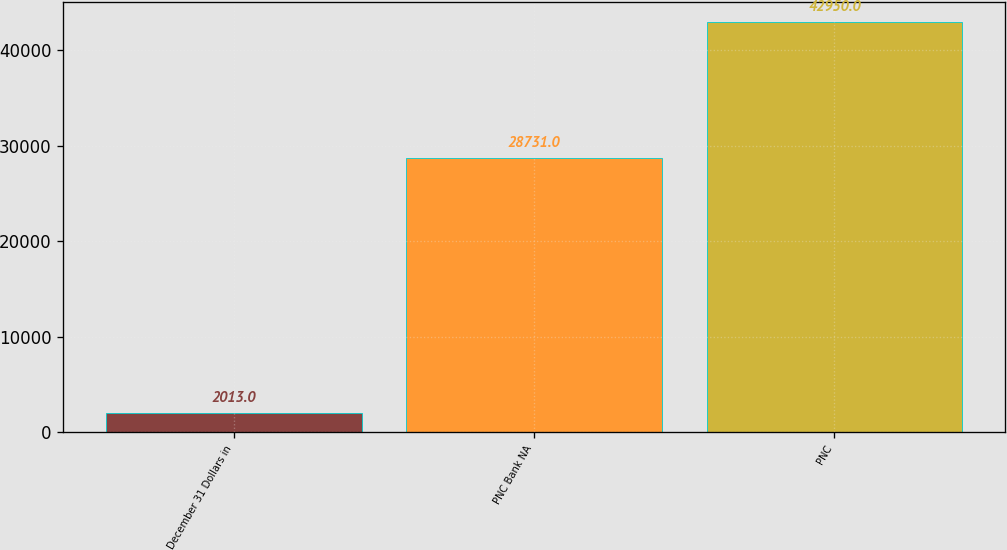Convert chart to OTSL. <chart><loc_0><loc_0><loc_500><loc_500><bar_chart><fcel>December 31 Dollars in<fcel>PNC Bank NA<fcel>PNC<nl><fcel>2013<fcel>28731<fcel>42950<nl></chart> 